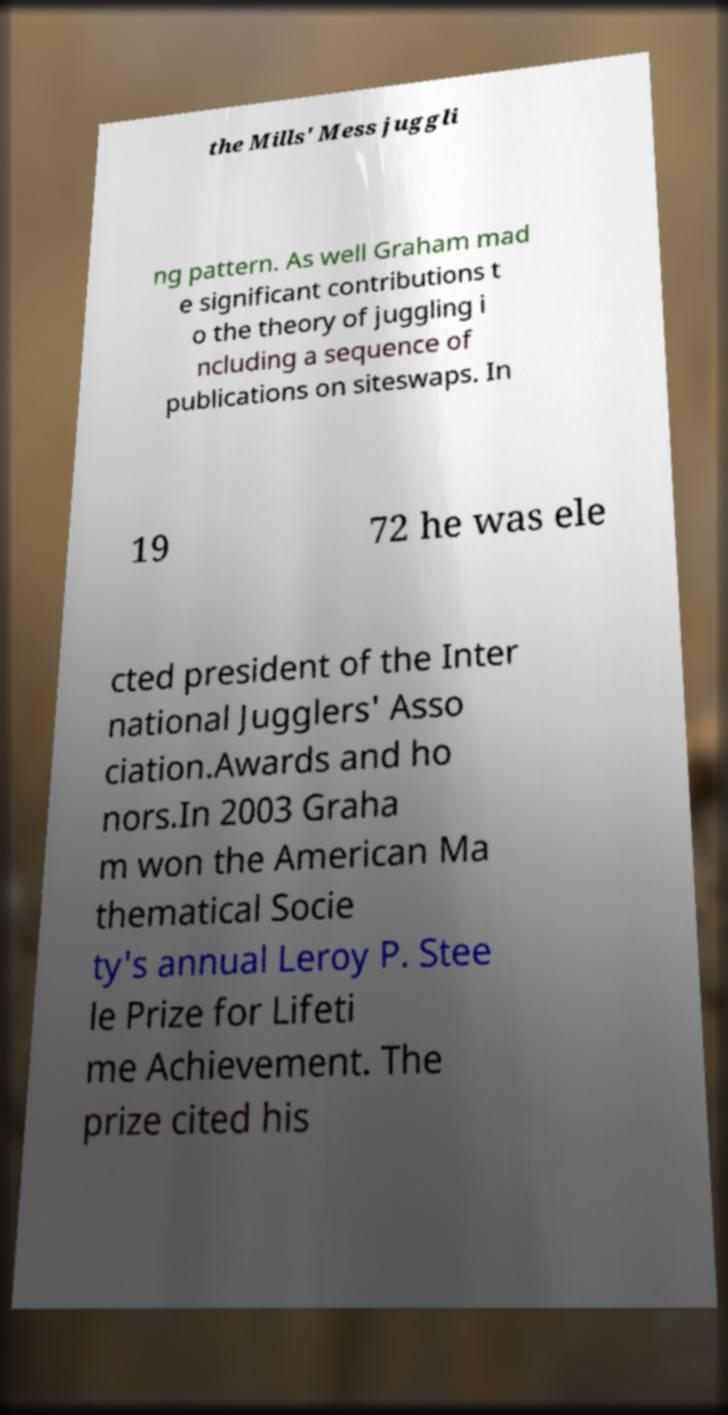Can you read and provide the text displayed in the image?This photo seems to have some interesting text. Can you extract and type it out for me? the Mills' Mess juggli ng pattern. As well Graham mad e significant contributions t o the theory of juggling i ncluding a sequence of publications on siteswaps. In 19 72 he was ele cted president of the Inter national Jugglers' Asso ciation.Awards and ho nors.In 2003 Graha m won the American Ma thematical Socie ty's annual Leroy P. Stee le Prize for Lifeti me Achievement. The prize cited his 